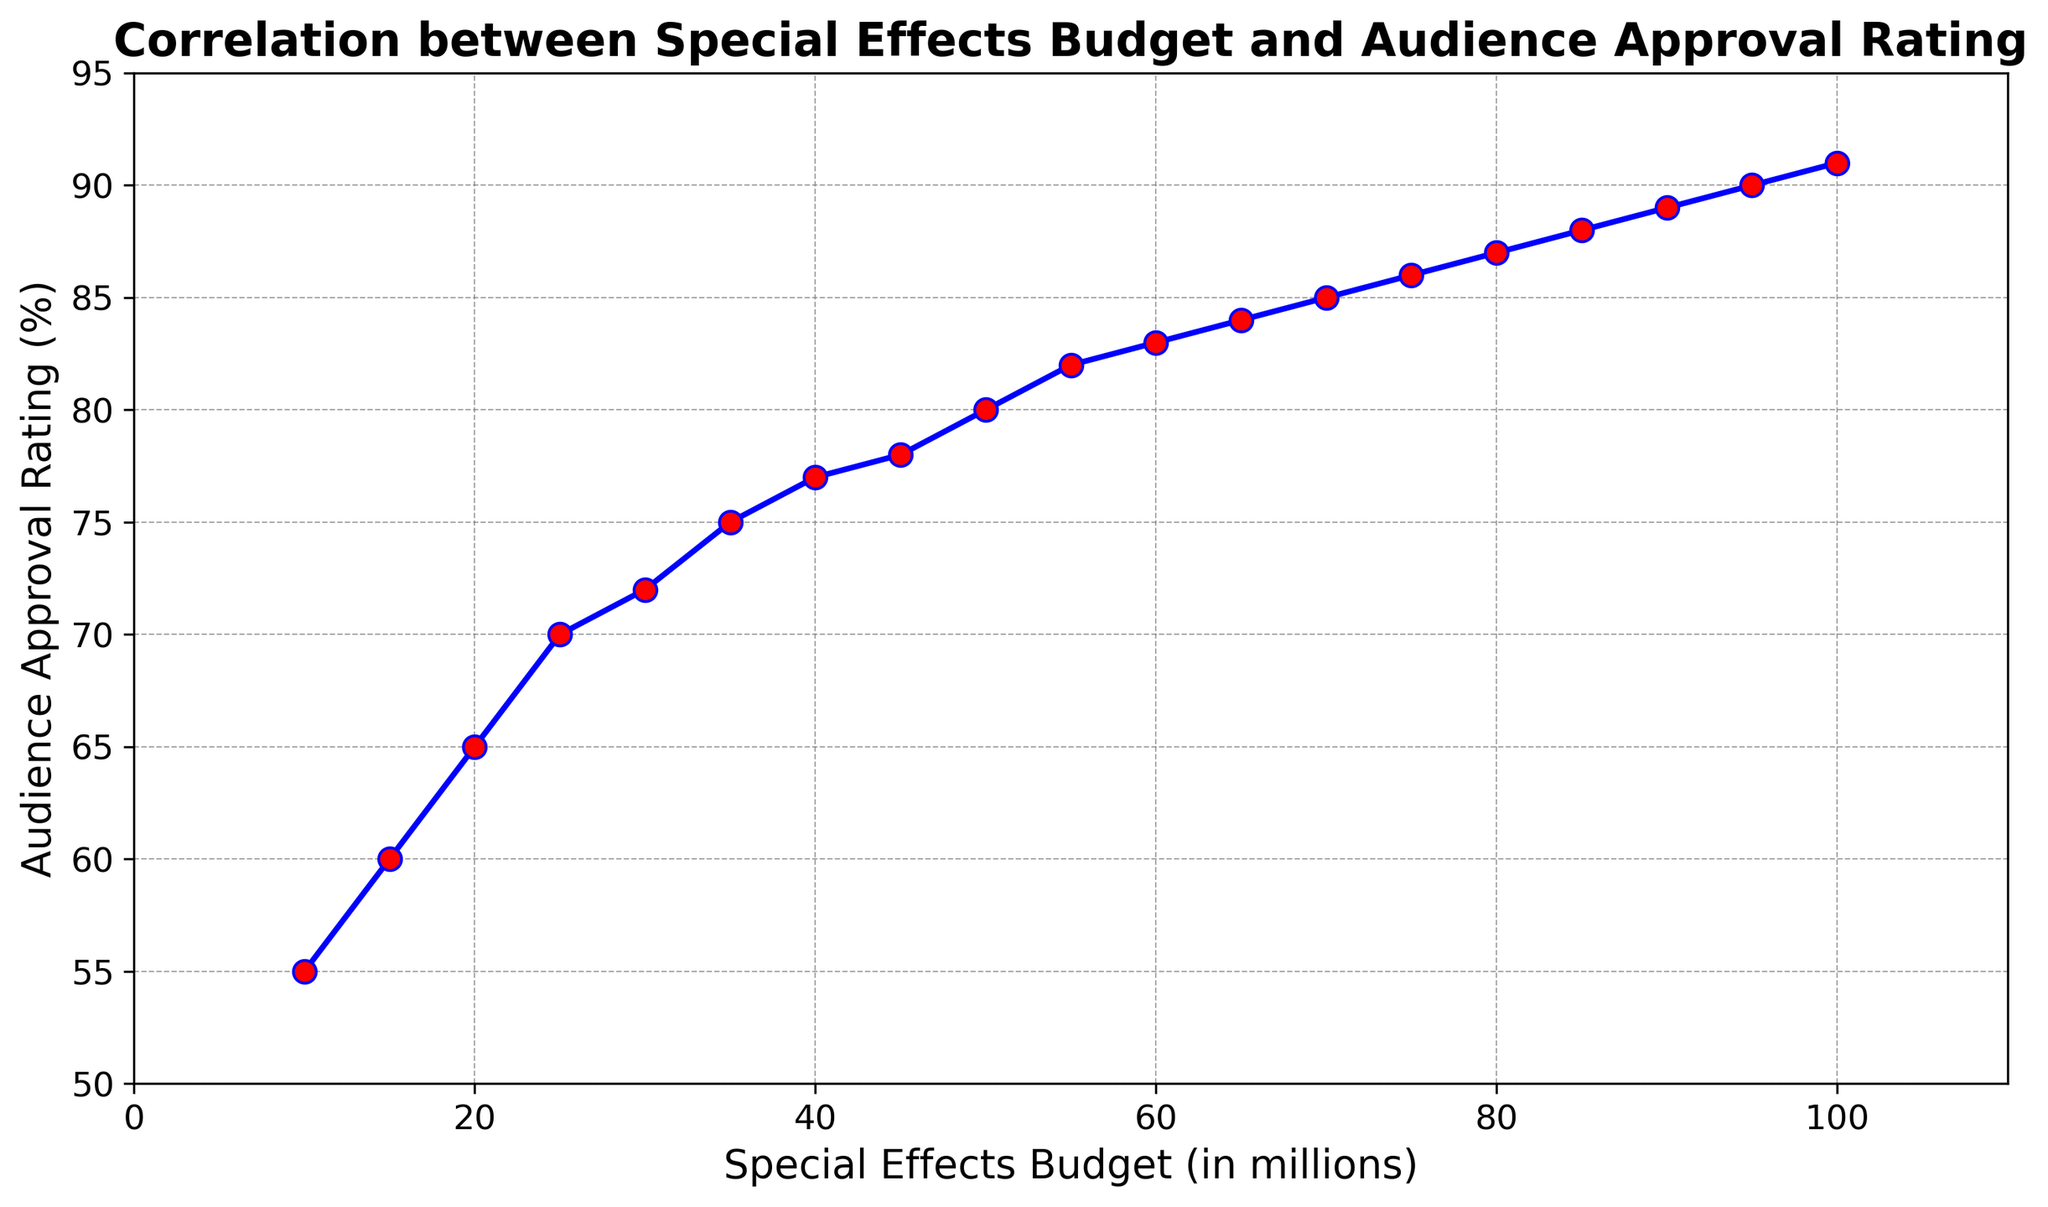What is the correlation between the special effects budget and audience approval rating? The relationship between the special effects budget and audience approval rating is shown by the upward trend of the line in the plot. As the budget increases, the audience rating also tends to increase. This indicates a positive correlation.
Answer: Positive At what special effects budget does the audience approval rating reach 80%? By looking at the plot, we can see that when the special effects budget is approximately $50 million, the audience approval rating reaches 80%.
Answer: $50 million What is the audience approval rating when the special effects budget is $100 million? According to the plot, the audience approval rating reaches 91% when the special effects budget is $100 million.
Answer: 91% Is there a point at which increasing the special effects budget does not significantly increase the audience approval rating? From the plot, it appears that after the special effects budget exceeds about $85 million, the increase in audience approval rating becomes much smaller, indicating diminishing returns.
Answer: $85 million What is the average audience approval rating for special effects budgets between $40 million and $60 million, inclusive? The ratings for budgets $40 million, $45 million, $50 million, $55 million, and $60 million are 77%, 78%, 80%, 82%, and 83%, respectively. The sum is (77+78+80+82+83) = 400. The average is 400/5 = 80%.
Answer: 80% Compare the audience approval ratings for special effects budgets of $20 million and $70 million. Which is higher and by how much? The audience approval rating for a budget of $20 million is 65%, and for $70 million, it is 85%. The difference is 85% - 65% = 20%.
Answer: $70 million is higher by 20% Which data point has the highest audience approval rating and what is its budget? The highest audience approval rating on the plot is 91%, which corresponds to a special effects budget of $100 million.
Answer: $100 million Describe the visual pattern shown in the plot line. The plot line shows a consistently upward trend with increasing special effects budget. The markers are red circles on a blue line, and the line is generally smooth with small increases in ratings at higher budgets.
Answer: Upward trend with red circles on a blue line How much does the audience approval rating change between a $10 million and $25 million budget? For a $10 million budget, the rating is 55%, and for a $25 million budget, it is 70%. The change is 70% - 55% = 15%.
Answer: 15% Identify the budget range where the audience approval rating surpasses 80%. By examining the plot, the audience approval rating surpasses 80% at a $50 million budget and continues to rise beyond that point.
Answer: Above $50 million 